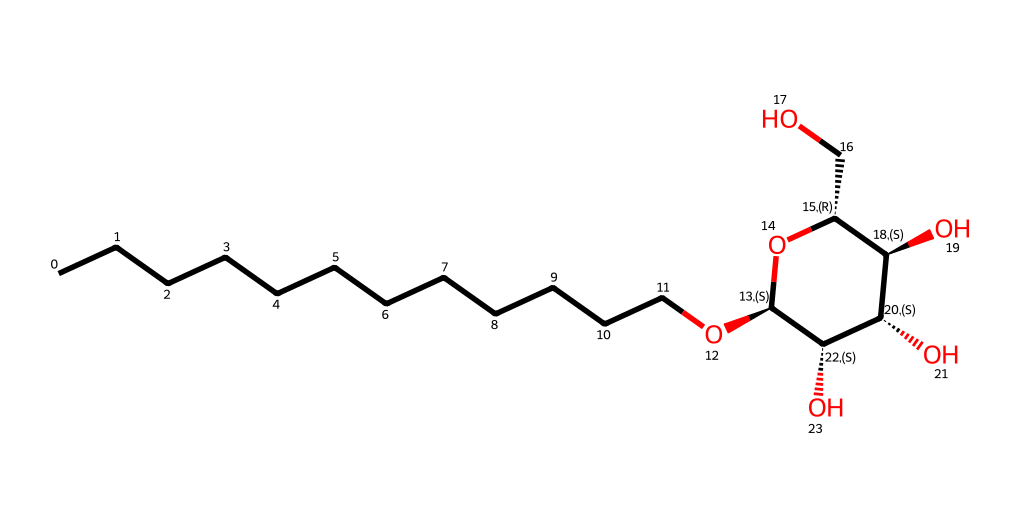What is the number of carbon atoms in this compound? The structure in the SMILES representation shows a long hydrocarbon chain (the "CCCCCCCCCCCC" part), which indicates that there are 12 carbon atoms. Counting the 'C' symbols, we determine that it is indeed 12.
Answer: 12 How many oxygen atoms are present? In the SMILES, we see the "O" symbols representing oxygen. There are three "O" symbols in total, indicating that there are three oxygen atoms present in the structure.
Answer: 3 What type of surfactant is represented by this compound? Alkyl polyglucosides are non-ionic surfactants. This compound, which has both a hydrophobic alkyl chain and hydrophilic sugar units, classifies it as a non-ionic surfactant due to the presence of the polyglucoside.
Answer: non-ionic surfactant What is the functional group indicated by the presence of the hydroxyl (-OH) groups? The "O" in the "C@H(O)" segments indicates the presence of hydroxyl groups. These groups are responsible for the compound's hydrophilic properties, characteristic of sugar alcohols relevant in cleaning applications.
Answer: hydroxyl groups How does the carbon chain length influence the surfactant's properties? The length of the carbon chain affects the surfactant's hydrophobic character; a longer chain typically increases surface activity and lowering of surface tension, enhancing the cleaning properties. Thus, a 12-carbon chain suggests effective cleaning capability.
Answer: enhances cleaning properties What is the role of the glucose units in this surfactant? The glucose units provide hydrophilicity to the molecule, allowing it to interact with water and other polar substances, resulting in better emulsification and solubilization properties in cleaning products.
Answer: provide hydrophilicity 